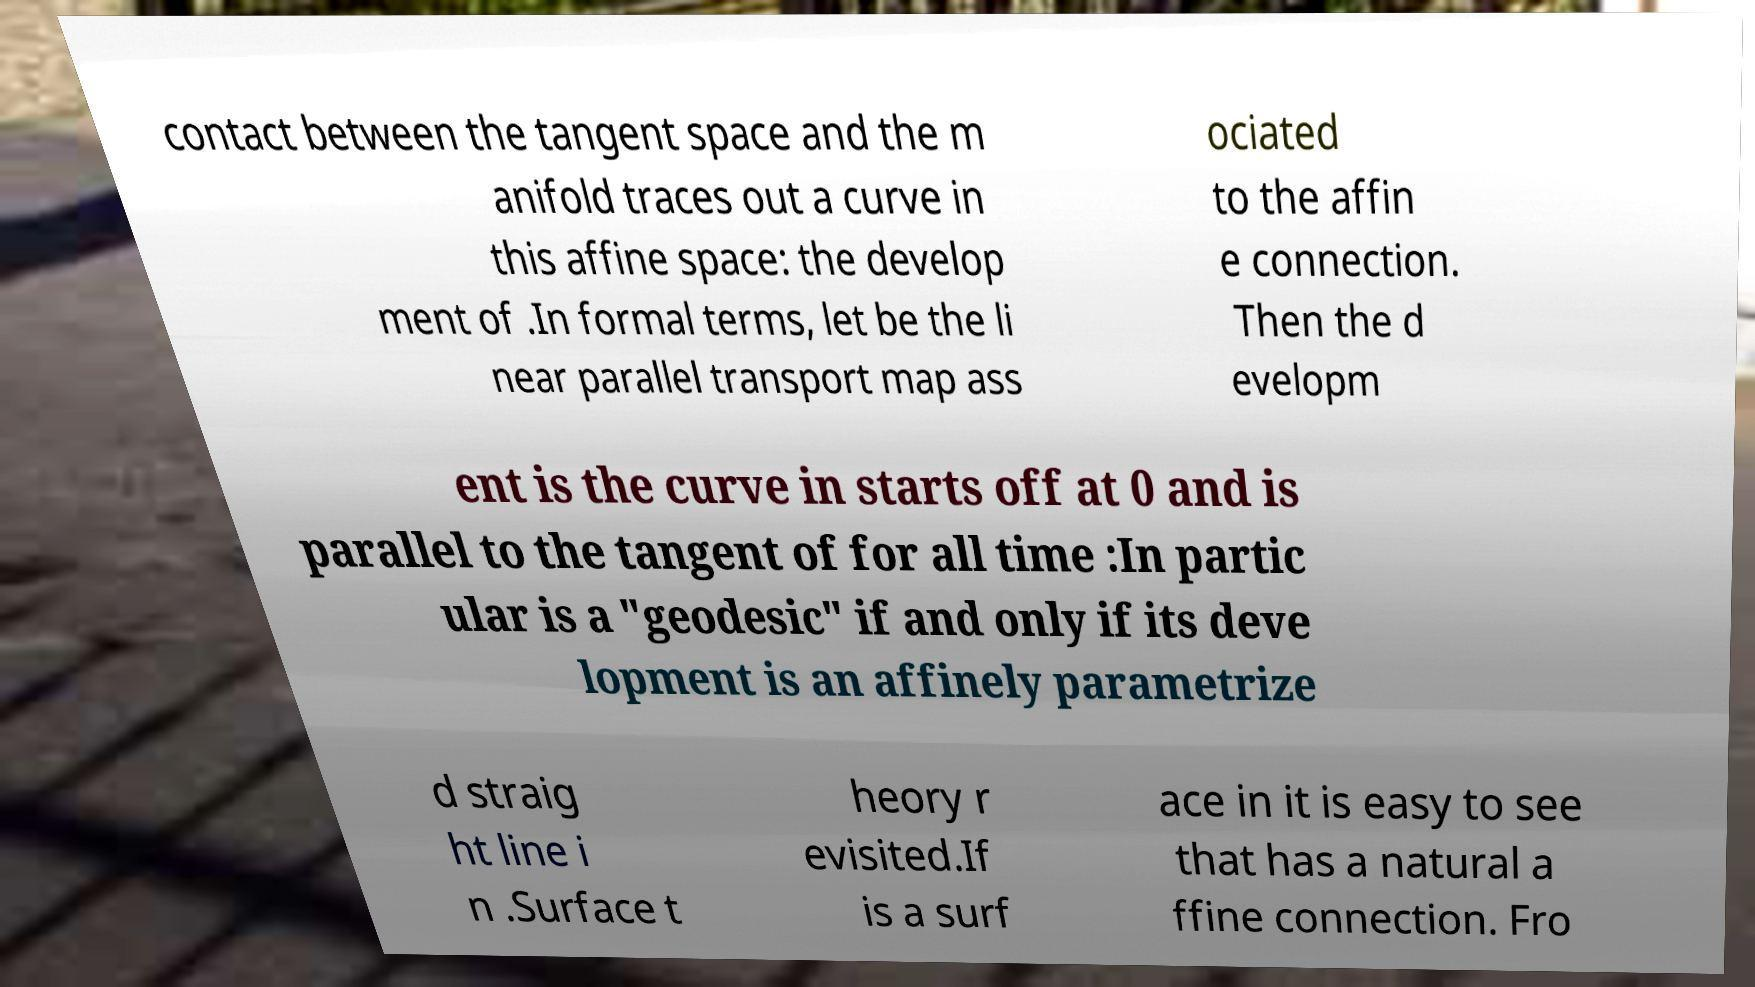Could you assist in decoding the text presented in this image and type it out clearly? contact between the tangent space and the m anifold traces out a curve in this affine space: the develop ment of .In formal terms, let be the li near parallel transport map ass ociated to the affin e connection. Then the d evelopm ent is the curve in starts off at 0 and is parallel to the tangent of for all time :In partic ular is a "geodesic" if and only if its deve lopment is an affinely parametrize d straig ht line i n .Surface t heory r evisited.If is a surf ace in it is easy to see that has a natural a ffine connection. Fro 